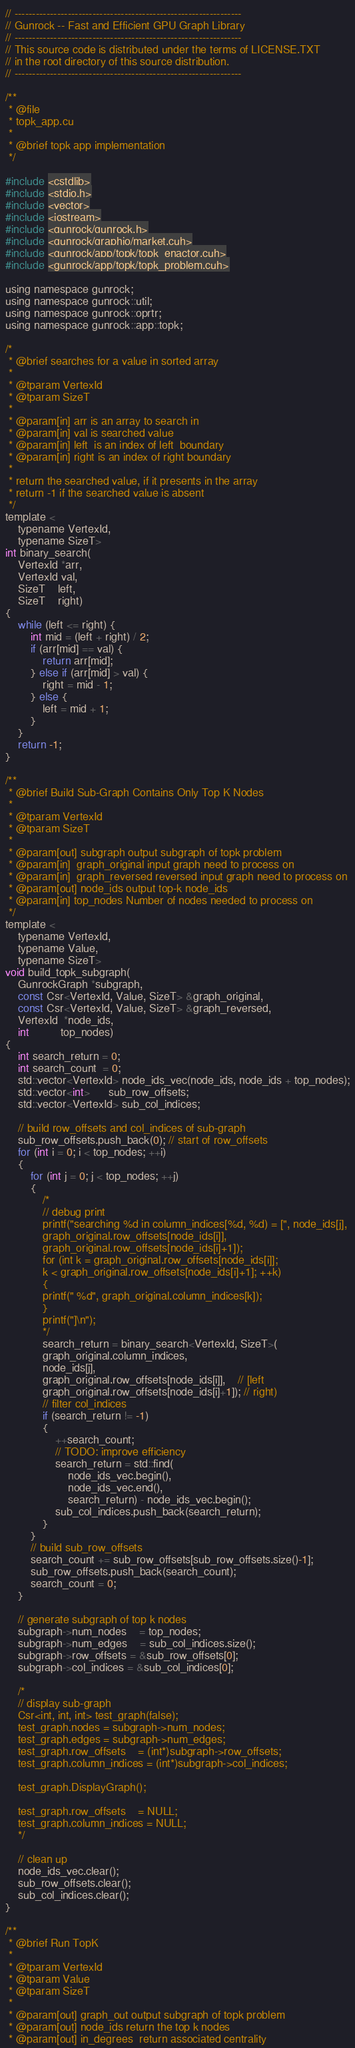Convert code to text. <code><loc_0><loc_0><loc_500><loc_500><_Cuda_>// ----------------------------------------------------------------
// Gunrock -- Fast and Efficient GPU Graph Library
// ----------------------------------------------------------------
// This source code is distributed under the terms of LICENSE.TXT
// in the root directory of this source distribution.
// ----------------------------------------------------------------

/**
 * @file
 * topk_app.cu
 *
 * @brief topk app implementation
 */

#include <cstdlib>
#include <stdio.h>
#include <vector>
#include <iostream>
#include <gunrock/gunrock.h>
#include <gunrock/graphio/market.cuh>
#include <gunrock/app/topk/topk_enactor.cuh>
#include <gunrock/app/topk/topk_problem.cuh>

using namespace gunrock;
using namespace gunrock::util;
using namespace gunrock::oprtr;
using namespace gunrock::app::topk;

/*
 * @brief searches for a value in sorted array
 *
 * @tparam VertexId
 * @tparam SizeT
 *
 * @param[in] arr is an array to search in
 * @param[in] val is searched value
 * @param[in] left  is an index of left  boundary
 * @param[in] right is an index of right boundary
 *
 * return the searched value, if it presents in the array
 * return -1 if the searched value is absent
 */
template <
    typename VertexId,
    typename SizeT>
int binary_search(
    VertexId *arr,
    VertexId val,
    SizeT    left,
    SizeT    right)
{
    while (left <= right) {
		int mid = (left + right) / 2;
		if (arr[mid] == val) {
		    return arr[mid];
		} else if (arr[mid] > val) {
		    right = mid - 1;
		} else {
		    left = mid + 1;
		}
    }
    return -1;
}

/**
 * @brief Build Sub-Graph Contains Only Top K Nodes
 *
 * @tparam VertexId
 * @tparam SizeT
 *
 * @param[out] subgraph output subgraph of topk problem
 * @param[in]  graph_original input graph need to process on
 * @param[in]  graph_reversed reversed input graph need to process on
 * @param[out] node_ids output top-k node_ids
 * @param[in] top_nodes Number of nodes needed to process on
 */
template <
    typename VertexId,
    typename Value,
    typename SizeT>
void build_topk_subgraph(
    GunrockGraph *subgraph,
    const Csr<VertexId, Value, SizeT> &graph_original,
    const Csr<VertexId, Value, SizeT> &graph_reversed,
    VertexId  *node_ids,
    int	      top_nodes)
{
    int search_return = 0;
    int search_count  = 0;
    std::vector<VertexId> node_ids_vec(node_ids, node_ids + top_nodes);
    std::vector<int>      sub_row_offsets;
    std::vector<VertexId> sub_col_indices;

    // build row_offsets and col_indices of sub-graph
    sub_row_offsets.push_back(0); // start of row_offsets
    for (int i = 0; i < top_nodes; ++i)
    {
		for (int j = 0; j < top_nodes; ++j)
		{
		    /*
		    // debug print
		    printf("searching %d in column_indices[%d, %d) = [", node_ids[j],
		    graph_original.row_offsets[node_ids[i]],
		    graph_original.row_offsets[node_ids[i]+1]);
		    for (int k = graph_original.row_offsets[node_ids[i]];
		    k < graph_original.row_offsets[node_ids[i]+1]; ++k)
		    {
		    printf(" %d", graph_original.column_indices[k]);
		    }
		    printf("]\n");
		    */
		    search_return = binary_search<VertexId, SizeT>(
			graph_original.column_indices,
			node_ids[j],
			graph_original.row_offsets[node_ids[i]],    // [left
			graph_original.row_offsets[node_ids[i]+1]); // right)
		    // filter col_indices
		    if (search_return != -1)
		    {
				++search_count;
				// TODO: improve efficiency
				search_return = std::find(
				    node_ids_vec.begin(),
				    node_ids_vec.end(),
				    search_return) - node_ids_vec.begin();
				sub_col_indices.push_back(search_return);
		    }
		}
		// build sub_row_offsets
		search_count += sub_row_offsets[sub_row_offsets.size()-1];
		sub_row_offsets.push_back(search_count);
		search_count = 0;
    }

    // generate subgraph of top k nodes
    subgraph->num_nodes	= top_nodes;
    subgraph->num_edges	= sub_col_indices.size();
    subgraph->row_offsets = &sub_row_offsets[0];
    subgraph->col_indices = &sub_col_indices[0];

    /*
    // display sub-graph
    Csr<int, int, int> test_graph(false);
    test_graph.nodes = subgraph->num_nodes;
    test_graph.edges = subgraph->num_edges;
    test_graph.row_offsets    = (int*)subgraph->row_offsets;
    test_graph.column_indices = (int*)subgraph->col_indices;

    test_graph.DisplayGraph();

    test_graph.row_offsets    = NULL;
    test_graph.column_indices = NULL;
    */

    // clean up
    node_ids_vec.clear();
    sub_row_offsets.clear();
    sub_col_indices.clear();
}

/**
 * @brief Run TopK
 *
 * @tparam VertexId
 * @tparam Value
 * @tparam SizeT
 *
 * @param[out] graph_out output subgraph of topk problem
 * @param[out] node_ids return the top k nodes
 * @param[out] in_degrees  return associated centrality</code> 